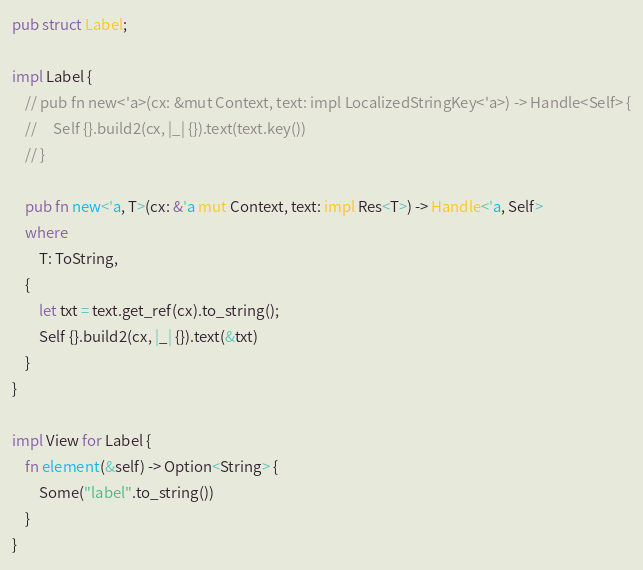<code> <loc_0><loc_0><loc_500><loc_500><_Rust_>pub struct Label;

impl Label {
    // pub fn new<'a>(cx: &mut Context, text: impl LocalizedStringKey<'a>) -> Handle<Self> {
    //     Self {}.build2(cx, |_| {}).text(text.key())
    // }

    pub fn new<'a, T>(cx: &'a mut Context, text: impl Res<T>) -> Handle<'a, Self>
    where
        T: ToString,
    {
        let txt = text.get_ref(cx).to_string();
        Self {}.build2(cx, |_| {}).text(&txt)
    }
}

impl View for Label {
    fn element(&self) -> Option<String> {
        Some("label".to_string())
    }
}
</code> 